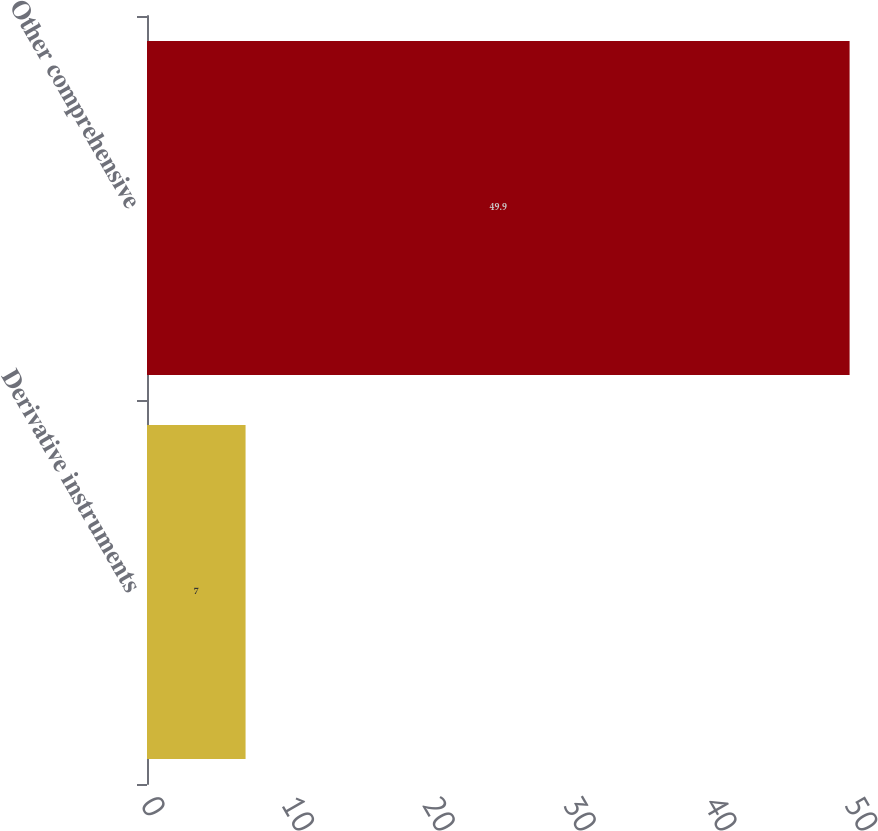Convert chart. <chart><loc_0><loc_0><loc_500><loc_500><bar_chart><fcel>Derivative instruments<fcel>Other comprehensive<nl><fcel>7<fcel>49.9<nl></chart> 